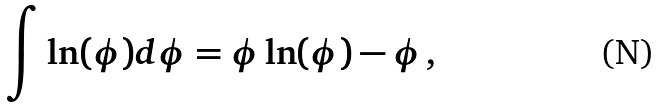Convert formula to latex. <formula><loc_0><loc_0><loc_500><loc_500>\int \ln ( \phi ) d \phi = \phi \ln ( \phi ) - \phi \, ,</formula> 